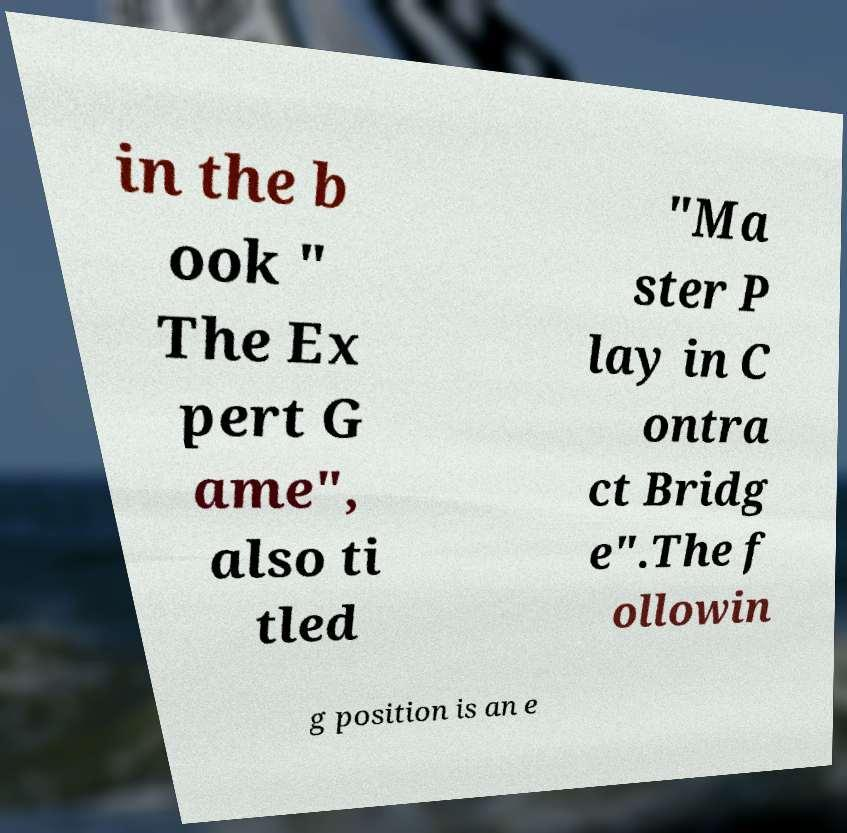Could you assist in decoding the text presented in this image and type it out clearly? in the b ook " The Ex pert G ame", also ti tled "Ma ster P lay in C ontra ct Bridg e".The f ollowin g position is an e 